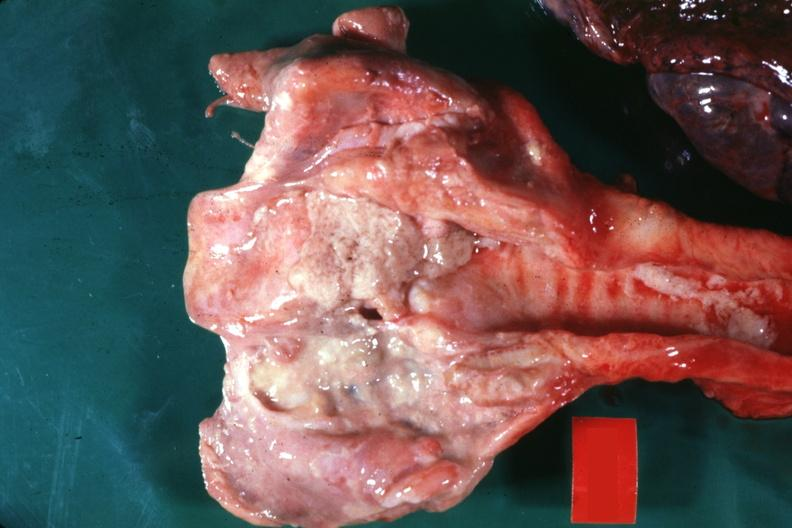what is present?
Answer the question using a single word or phrase. Larynx 